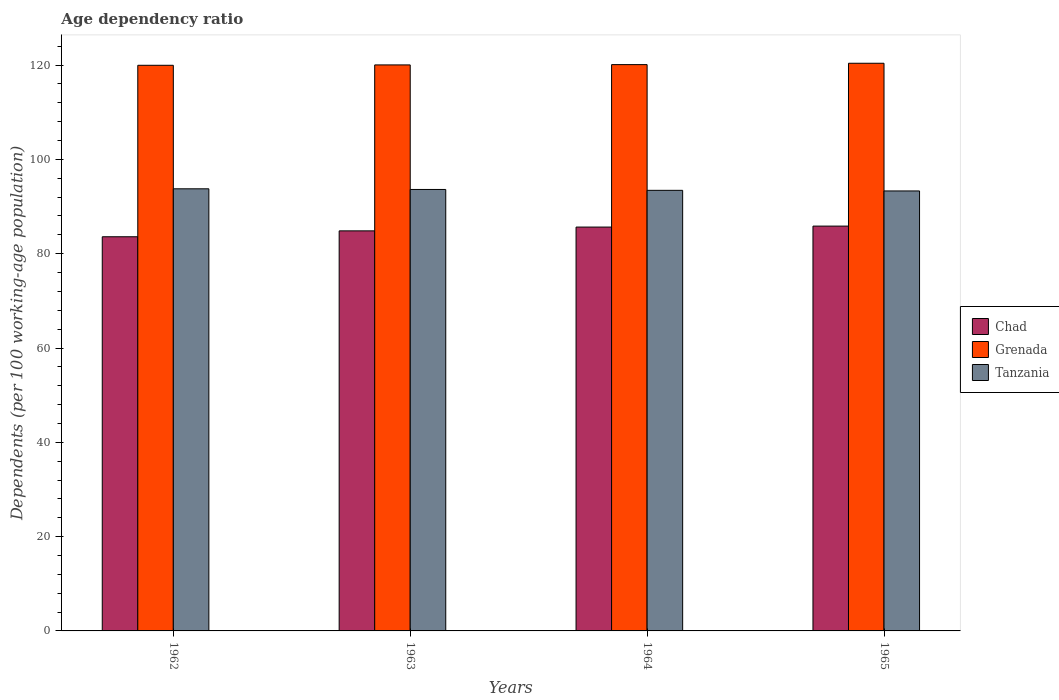How many bars are there on the 1st tick from the left?
Your response must be concise. 3. What is the label of the 3rd group of bars from the left?
Your answer should be very brief. 1964. In how many cases, is the number of bars for a given year not equal to the number of legend labels?
Ensure brevity in your answer.  0. What is the age dependency ratio in in Grenada in 1964?
Ensure brevity in your answer.  120.1. Across all years, what is the maximum age dependency ratio in in Tanzania?
Offer a terse response. 93.77. Across all years, what is the minimum age dependency ratio in in Grenada?
Provide a short and direct response. 119.96. In which year was the age dependency ratio in in Chad maximum?
Make the answer very short. 1965. In which year was the age dependency ratio in in Chad minimum?
Ensure brevity in your answer.  1962. What is the total age dependency ratio in in Grenada in the graph?
Provide a succinct answer. 480.5. What is the difference between the age dependency ratio in in Chad in 1962 and that in 1965?
Your answer should be compact. -2.26. What is the difference between the age dependency ratio in in Tanzania in 1965 and the age dependency ratio in in Grenada in 1963?
Offer a terse response. -26.73. What is the average age dependency ratio in in Grenada per year?
Ensure brevity in your answer.  120.12. In the year 1962, what is the difference between the age dependency ratio in in Tanzania and age dependency ratio in in Grenada?
Your answer should be very brief. -26.2. What is the ratio of the age dependency ratio in in Chad in 1964 to that in 1965?
Your answer should be very brief. 1. Is the difference between the age dependency ratio in in Tanzania in 1963 and 1965 greater than the difference between the age dependency ratio in in Grenada in 1963 and 1965?
Your answer should be very brief. Yes. What is the difference between the highest and the second highest age dependency ratio in in Grenada?
Make the answer very short. 0.29. What is the difference between the highest and the lowest age dependency ratio in in Grenada?
Your response must be concise. 0.43. What does the 1st bar from the left in 1962 represents?
Your response must be concise. Chad. What does the 2nd bar from the right in 1965 represents?
Your answer should be very brief. Grenada. How many years are there in the graph?
Your answer should be compact. 4. What is the difference between two consecutive major ticks on the Y-axis?
Offer a very short reply. 20. Are the values on the major ticks of Y-axis written in scientific E-notation?
Your answer should be very brief. No. Does the graph contain any zero values?
Give a very brief answer. No. Where does the legend appear in the graph?
Provide a short and direct response. Center right. How are the legend labels stacked?
Give a very brief answer. Vertical. What is the title of the graph?
Provide a short and direct response. Age dependency ratio. What is the label or title of the Y-axis?
Make the answer very short. Dependents (per 100 working-age population). What is the Dependents (per 100 working-age population) of Chad in 1962?
Offer a very short reply. 83.6. What is the Dependents (per 100 working-age population) in Grenada in 1962?
Your answer should be compact. 119.96. What is the Dependents (per 100 working-age population) in Tanzania in 1962?
Ensure brevity in your answer.  93.77. What is the Dependents (per 100 working-age population) of Chad in 1963?
Offer a terse response. 84.84. What is the Dependents (per 100 working-age population) of Grenada in 1963?
Provide a succinct answer. 120.04. What is the Dependents (per 100 working-age population) in Tanzania in 1963?
Your answer should be compact. 93.63. What is the Dependents (per 100 working-age population) in Chad in 1964?
Make the answer very short. 85.65. What is the Dependents (per 100 working-age population) of Grenada in 1964?
Provide a short and direct response. 120.1. What is the Dependents (per 100 working-age population) in Tanzania in 1964?
Ensure brevity in your answer.  93.44. What is the Dependents (per 100 working-age population) in Chad in 1965?
Provide a succinct answer. 85.86. What is the Dependents (per 100 working-age population) in Grenada in 1965?
Provide a succinct answer. 120.39. What is the Dependents (per 100 working-age population) in Tanzania in 1965?
Keep it short and to the point. 93.31. Across all years, what is the maximum Dependents (per 100 working-age population) of Chad?
Your answer should be compact. 85.86. Across all years, what is the maximum Dependents (per 100 working-age population) of Grenada?
Offer a very short reply. 120.39. Across all years, what is the maximum Dependents (per 100 working-age population) of Tanzania?
Your response must be concise. 93.77. Across all years, what is the minimum Dependents (per 100 working-age population) in Chad?
Provide a short and direct response. 83.6. Across all years, what is the minimum Dependents (per 100 working-age population) of Grenada?
Your answer should be very brief. 119.96. Across all years, what is the minimum Dependents (per 100 working-age population) of Tanzania?
Your response must be concise. 93.31. What is the total Dependents (per 100 working-age population) in Chad in the graph?
Make the answer very short. 339.94. What is the total Dependents (per 100 working-age population) of Grenada in the graph?
Offer a terse response. 480.5. What is the total Dependents (per 100 working-age population) of Tanzania in the graph?
Ensure brevity in your answer.  374.14. What is the difference between the Dependents (per 100 working-age population) of Chad in 1962 and that in 1963?
Give a very brief answer. -1.25. What is the difference between the Dependents (per 100 working-age population) of Grenada in 1962 and that in 1963?
Give a very brief answer. -0.08. What is the difference between the Dependents (per 100 working-age population) of Tanzania in 1962 and that in 1963?
Your answer should be compact. 0.14. What is the difference between the Dependents (per 100 working-age population) of Chad in 1962 and that in 1964?
Your answer should be very brief. -2.05. What is the difference between the Dependents (per 100 working-age population) in Grenada in 1962 and that in 1964?
Provide a succinct answer. -0.14. What is the difference between the Dependents (per 100 working-age population) in Tanzania in 1962 and that in 1964?
Your answer should be compact. 0.33. What is the difference between the Dependents (per 100 working-age population) of Chad in 1962 and that in 1965?
Provide a succinct answer. -2.26. What is the difference between the Dependents (per 100 working-age population) in Grenada in 1962 and that in 1965?
Provide a short and direct response. -0.43. What is the difference between the Dependents (per 100 working-age population) in Tanzania in 1962 and that in 1965?
Ensure brevity in your answer.  0.46. What is the difference between the Dependents (per 100 working-age population) in Chad in 1963 and that in 1964?
Provide a short and direct response. -0.8. What is the difference between the Dependents (per 100 working-age population) in Grenada in 1963 and that in 1964?
Provide a short and direct response. -0.06. What is the difference between the Dependents (per 100 working-age population) in Tanzania in 1963 and that in 1964?
Provide a short and direct response. 0.19. What is the difference between the Dependents (per 100 working-age population) in Chad in 1963 and that in 1965?
Give a very brief answer. -1.01. What is the difference between the Dependents (per 100 working-age population) in Grenada in 1963 and that in 1965?
Offer a terse response. -0.35. What is the difference between the Dependents (per 100 working-age population) of Tanzania in 1963 and that in 1965?
Offer a terse response. 0.32. What is the difference between the Dependents (per 100 working-age population) of Chad in 1964 and that in 1965?
Provide a succinct answer. -0.21. What is the difference between the Dependents (per 100 working-age population) in Grenada in 1964 and that in 1965?
Keep it short and to the point. -0.29. What is the difference between the Dependents (per 100 working-age population) of Tanzania in 1964 and that in 1965?
Provide a succinct answer. 0.13. What is the difference between the Dependents (per 100 working-age population) in Chad in 1962 and the Dependents (per 100 working-age population) in Grenada in 1963?
Your answer should be compact. -36.44. What is the difference between the Dependents (per 100 working-age population) in Chad in 1962 and the Dependents (per 100 working-age population) in Tanzania in 1963?
Give a very brief answer. -10.03. What is the difference between the Dependents (per 100 working-age population) of Grenada in 1962 and the Dependents (per 100 working-age population) of Tanzania in 1963?
Your answer should be very brief. 26.34. What is the difference between the Dependents (per 100 working-age population) in Chad in 1962 and the Dependents (per 100 working-age population) in Grenada in 1964?
Your answer should be very brief. -36.51. What is the difference between the Dependents (per 100 working-age population) of Chad in 1962 and the Dependents (per 100 working-age population) of Tanzania in 1964?
Offer a very short reply. -9.84. What is the difference between the Dependents (per 100 working-age population) in Grenada in 1962 and the Dependents (per 100 working-age population) in Tanzania in 1964?
Give a very brief answer. 26.52. What is the difference between the Dependents (per 100 working-age population) of Chad in 1962 and the Dependents (per 100 working-age population) of Grenada in 1965?
Offer a terse response. -36.8. What is the difference between the Dependents (per 100 working-age population) of Chad in 1962 and the Dependents (per 100 working-age population) of Tanzania in 1965?
Make the answer very short. -9.71. What is the difference between the Dependents (per 100 working-age population) of Grenada in 1962 and the Dependents (per 100 working-age population) of Tanzania in 1965?
Give a very brief answer. 26.65. What is the difference between the Dependents (per 100 working-age population) of Chad in 1963 and the Dependents (per 100 working-age population) of Grenada in 1964?
Your answer should be very brief. -35.26. What is the difference between the Dependents (per 100 working-age population) of Chad in 1963 and the Dependents (per 100 working-age population) of Tanzania in 1964?
Your response must be concise. -8.59. What is the difference between the Dependents (per 100 working-age population) of Grenada in 1963 and the Dependents (per 100 working-age population) of Tanzania in 1964?
Offer a terse response. 26.6. What is the difference between the Dependents (per 100 working-age population) in Chad in 1963 and the Dependents (per 100 working-age population) in Grenada in 1965?
Your answer should be very brief. -35.55. What is the difference between the Dependents (per 100 working-age population) of Chad in 1963 and the Dependents (per 100 working-age population) of Tanzania in 1965?
Offer a very short reply. -8.47. What is the difference between the Dependents (per 100 working-age population) of Grenada in 1963 and the Dependents (per 100 working-age population) of Tanzania in 1965?
Make the answer very short. 26.73. What is the difference between the Dependents (per 100 working-age population) in Chad in 1964 and the Dependents (per 100 working-age population) in Grenada in 1965?
Your response must be concise. -34.74. What is the difference between the Dependents (per 100 working-age population) of Chad in 1964 and the Dependents (per 100 working-age population) of Tanzania in 1965?
Your answer should be compact. -7.66. What is the difference between the Dependents (per 100 working-age population) in Grenada in 1964 and the Dependents (per 100 working-age population) in Tanzania in 1965?
Give a very brief answer. 26.79. What is the average Dependents (per 100 working-age population) of Chad per year?
Offer a very short reply. 84.99. What is the average Dependents (per 100 working-age population) in Grenada per year?
Your answer should be compact. 120.12. What is the average Dependents (per 100 working-age population) of Tanzania per year?
Offer a terse response. 93.54. In the year 1962, what is the difference between the Dependents (per 100 working-age population) of Chad and Dependents (per 100 working-age population) of Grenada?
Your response must be concise. -36.37. In the year 1962, what is the difference between the Dependents (per 100 working-age population) in Chad and Dependents (per 100 working-age population) in Tanzania?
Give a very brief answer. -10.17. In the year 1962, what is the difference between the Dependents (per 100 working-age population) in Grenada and Dependents (per 100 working-age population) in Tanzania?
Your response must be concise. 26.2. In the year 1963, what is the difference between the Dependents (per 100 working-age population) of Chad and Dependents (per 100 working-age population) of Grenada?
Keep it short and to the point. -35.2. In the year 1963, what is the difference between the Dependents (per 100 working-age population) in Chad and Dependents (per 100 working-age population) in Tanzania?
Offer a terse response. -8.78. In the year 1963, what is the difference between the Dependents (per 100 working-age population) of Grenada and Dependents (per 100 working-age population) of Tanzania?
Your answer should be compact. 26.41. In the year 1964, what is the difference between the Dependents (per 100 working-age population) of Chad and Dependents (per 100 working-age population) of Grenada?
Ensure brevity in your answer.  -34.46. In the year 1964, what is the difference between the Dependents (per 100 working-age population) of Chad and Dependents (per 100 working-age population) of Tanzania?
Provide a short and direct response. -7.79. In the year 1964, what is the difference between the Dependents (per 100 working-age population) in Grenada and Dependents (per 100 working-age population) in Tanzania?
Your answer should be very brief. 26.66. In the year 1965, what is the difference between the Dependents (per 100 working-age population) in Chad and Dependents (per 100 working-age population) in Grenada?
Your response must be concise. -34.54. In the year 1965, what is the difference between the Dependents (per 100 working-age population) of Chad and Dependents (per 100 working-age population) of Tanzania?
Your answer should be compact. -7.46. In the year 1965, what is the difference between the Dependents (per 100 working-age population) of Grenada and Dependents (per 100 working-age population) of Tanzania?
Make the answer very short. 27.08. What is the ratio of the Dependents (per 100 working-age population) of Chad in 1962 to that in 1963?
Ensure brevity in your answer.  0.99. What is the ratio of the Dependents (per 100 working-age population) of Grenada in 1962 to that in 1963?
Give a very brief answer. 1. What is the ratio of the Dependents (per 100 working-age population) in Chad in 1962 to that in 1964?
Your response must be concise. 0.98. What is the ratio of the Dependents (per 100 working-age population) of Chad in 1962 to that in 1965?
Your answer should be compact. 0.97. What is the ratio of the Dependents (per 100 working-age population) in Grenada in 1962 to that in 1965?
Make the answer very short. 1. What is the ratio of the Dependents (per 100 working-age population) of Tanzania in 1962 to that in 1965?
Your answer should be compact. 1. What is the ratio of the Dependents (per 100 working-age population) of Chad in 1963 to that in 1964?
Provide a succinct answer. 0.99. What is the ratio of the Dependents (per 100 working-age population) of Grenada in 1963 to that in 1965?
Provide a succinct answer. 1. What is the ratio of the Dependents (per 100 working-age population) in Tanzania in 1963 to that in 1965?
Provide a short and direct response. 1. What is the ratio of the Dependents (per 100 working-age population) of Chad in 1964 to that in 1965?
Your answer should be very brief. 1. What is the ratio of the Dependents (per 100 working-age population) of Tanzania in 1964 to that in 1965?
Make the answer very short. 1. What is the difference between the highest and the second highest Dependents (per 100 working-age population) of Chad?
Provide a succinct answer. 0.21. What is the difference between the highest and the second highest Dependents (per 100 working-age population) in Grenada?
Offer a very short reply. 0.29. What is the difference between the highest and the second highest Dependents (per 100 working-age population) in Tanzania?
Your response must be concise. 0.14. What is the difference between the highest and the lowest Dependents (per 100 working-age population) in Chad?
Offer a terse response. 2.26. What is the difference between the highest and the lowest Dependents (per 100 working-age population) of Grenada?
Your answer should be compact. 0.43. What is the difference between the highest and the lowest Dependents (per 100 working-age population) in Tanzania?
Offer a very short reply. 0.46. 